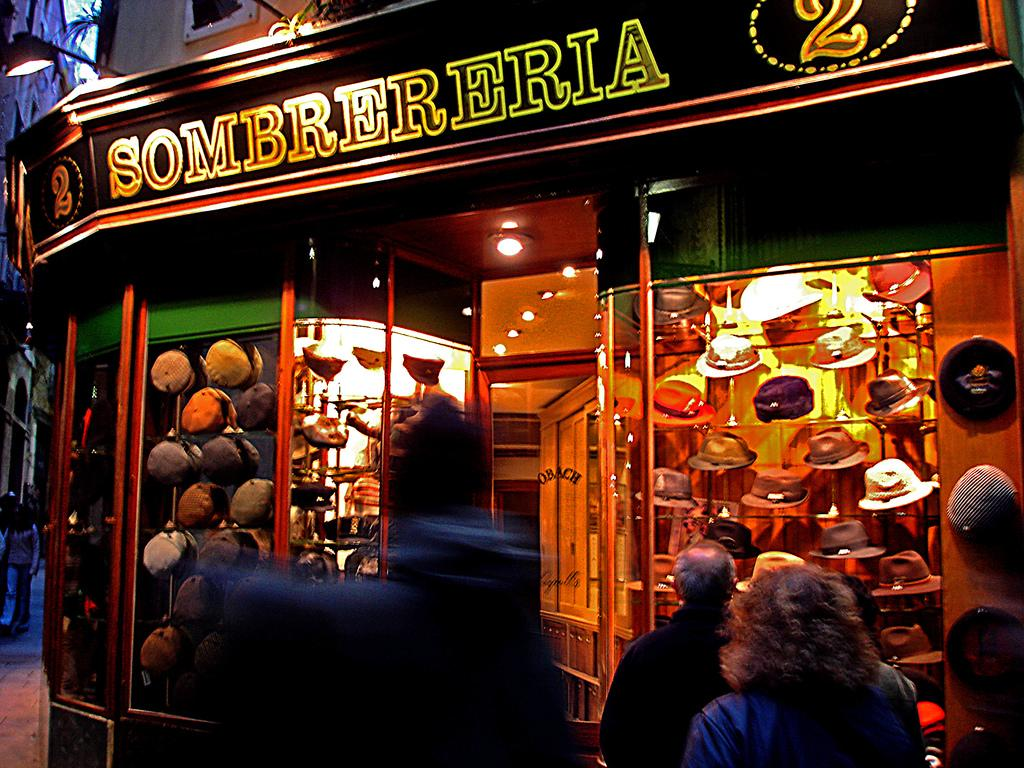What type of items are displayed in the shop? The shop showcases hats and caps. How are the hats and caps displayed in the shop? The hats and caps are displayed in glasses. What can be observed about the people near the shop? There are people standing in front of the shop, and they are watching the shop. How many hours does it take to travel to the island featured in the shop's window? There is no island present in the image, and therefore no information about traveling to an island can be provided. 